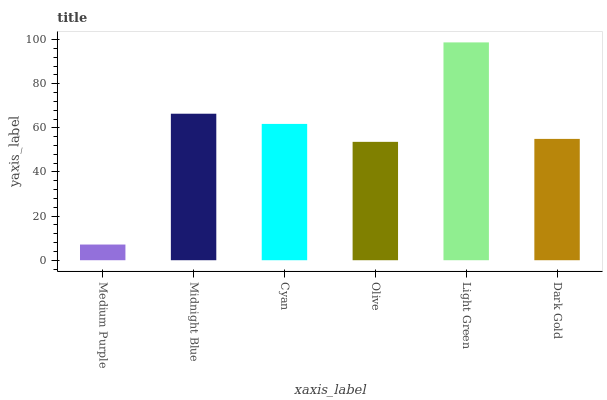Is Medium Purple the minimum?
Answer yes or no. Yes. Is Light Green the maximum?
Answer yes or no. Yes. Is Midnight Blue the minimum?
Answer yes or no. No. Is Midnight Blue the maximum?
Answer yes or no. No. Is Midnight Blue greater than Medium Purple?
Answer yes or no. Yes. Is Medium Purple less than Midnight Blue?
Answer yes or no. Yes. Is Medium Purple greater than Midnight Blue?
Answer yes or no. No. Is Midnight Blue less than Medium Purple?
Answer yes or no. No. Is Cyan the high median?
Answer yes or no. Yes. Is Dark Gold the low median?
Answer yes or no. Yes. Is Dark Gold the high median?
Answer yes or no. No. Is Medium Purple the low median?
Answer yes or no. No. 